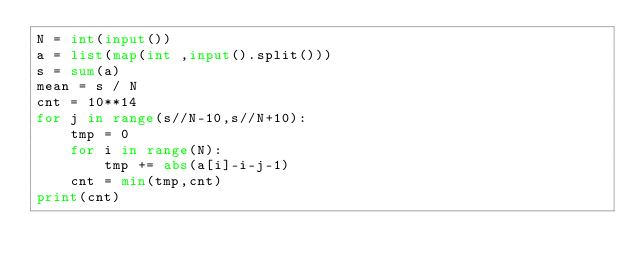Convert code to text. <code><loc_0><loc_0><loc_500><loc_500><_Python_>N = int(input())
a = list(map(int ,input().split()))
s = sum(a)
mean = s / N
cnt = 10**14
for j in range(s//N-10,s//N+10):
    tmp = 0
    for i in range(N):
        tmp += abs(a[i]-i-j-1)
    cnt = min(tmp,cnt)
print(cnt)</code> 